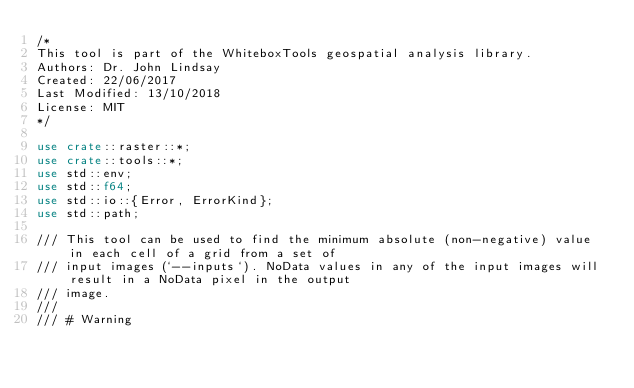<code> <loc_0><loc_0><loc_500><loc_500><_Rust_>/*
This tool is part of the WhiteboxTools geospatial analysis library.
Authors: Dr. John Lindsay
Created: 22/06/2017
Last Modified: 13/10/2018
License: MIT
*/

use crate::raster::*;
use crate::tools::*;
use std::env;
use std::f64;
use std::io::{Error, ErrorKind};
use std::path;

/// This tool can be used to find the minimum absolute (non-negative) value in each cell of a grid from a set of 
/// input images (`--inputs`). NoData values in any of the input images will result in a NoData pixel in the output 
/// image. 
/// 
/// # Warning</code> 